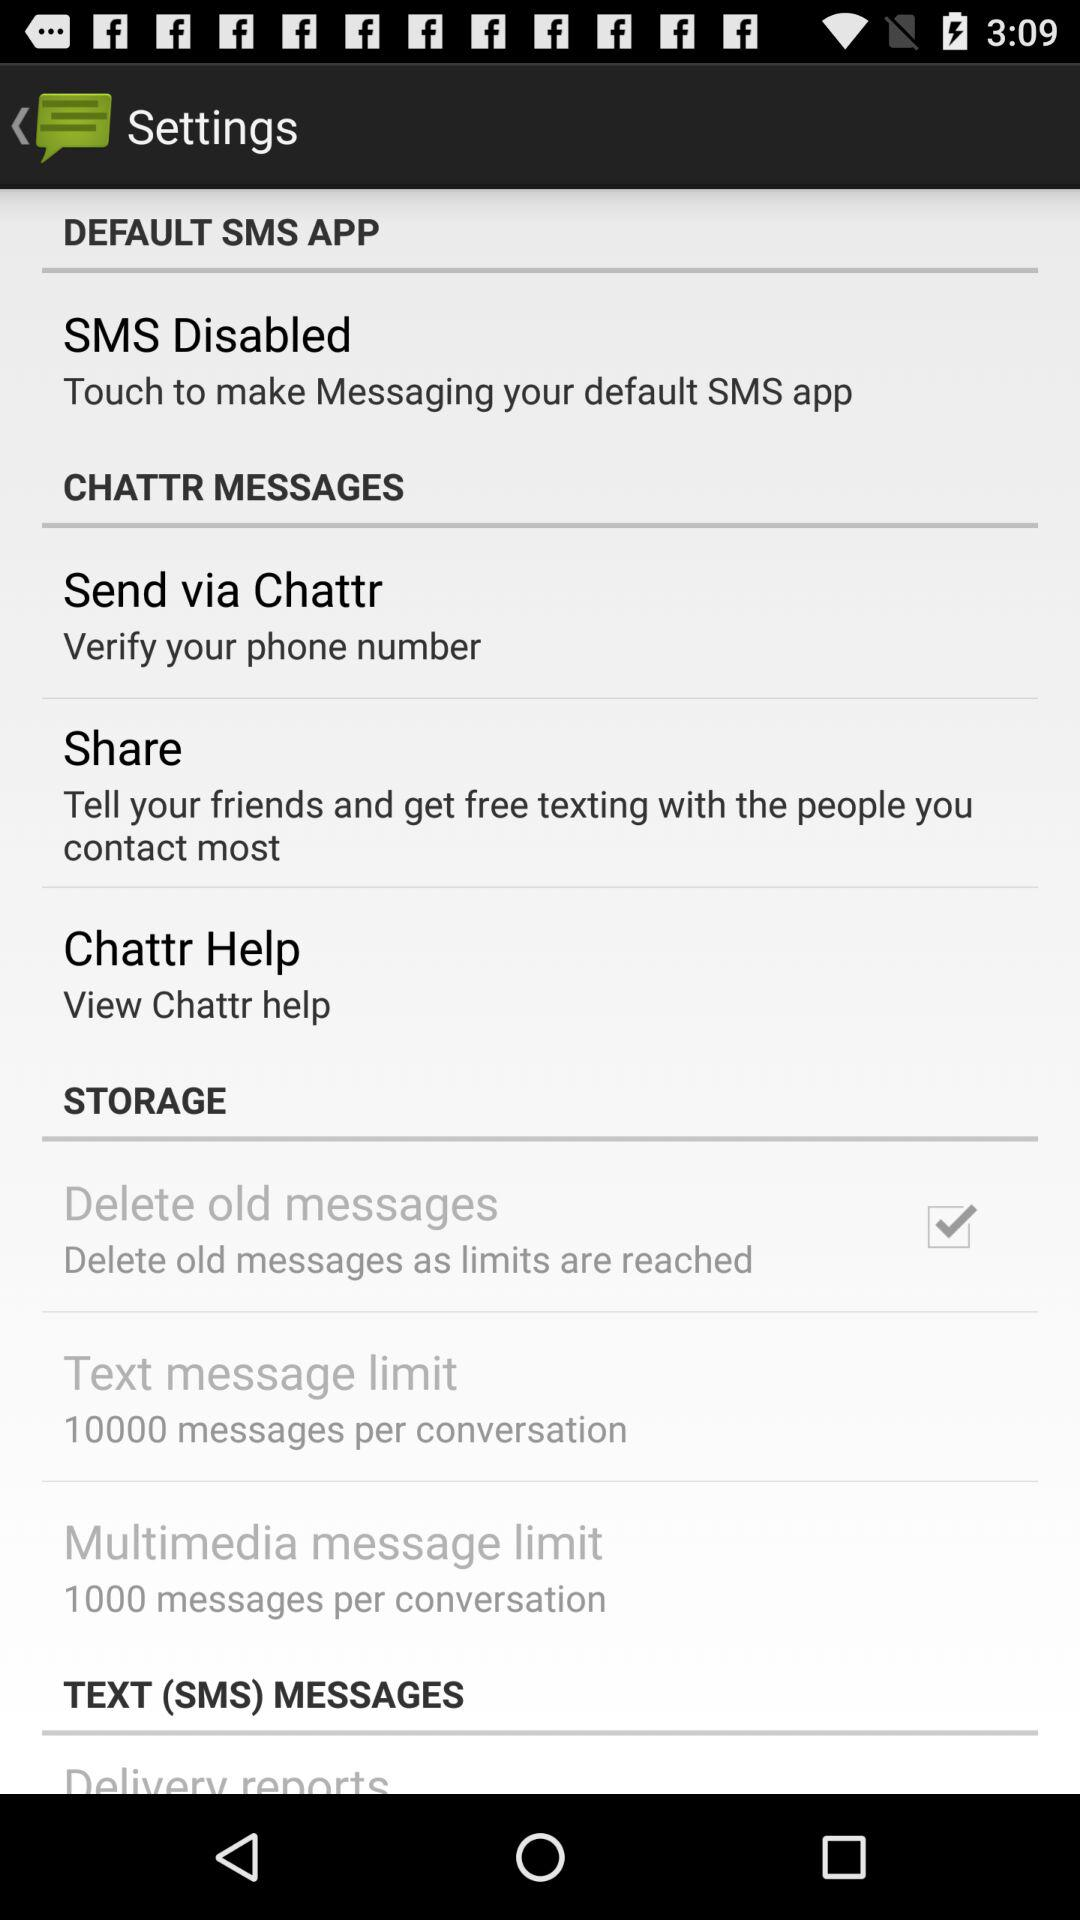How many more messages can I send using multimedia messages than text messages?
Answer the question using a single word or phrase. 9000 